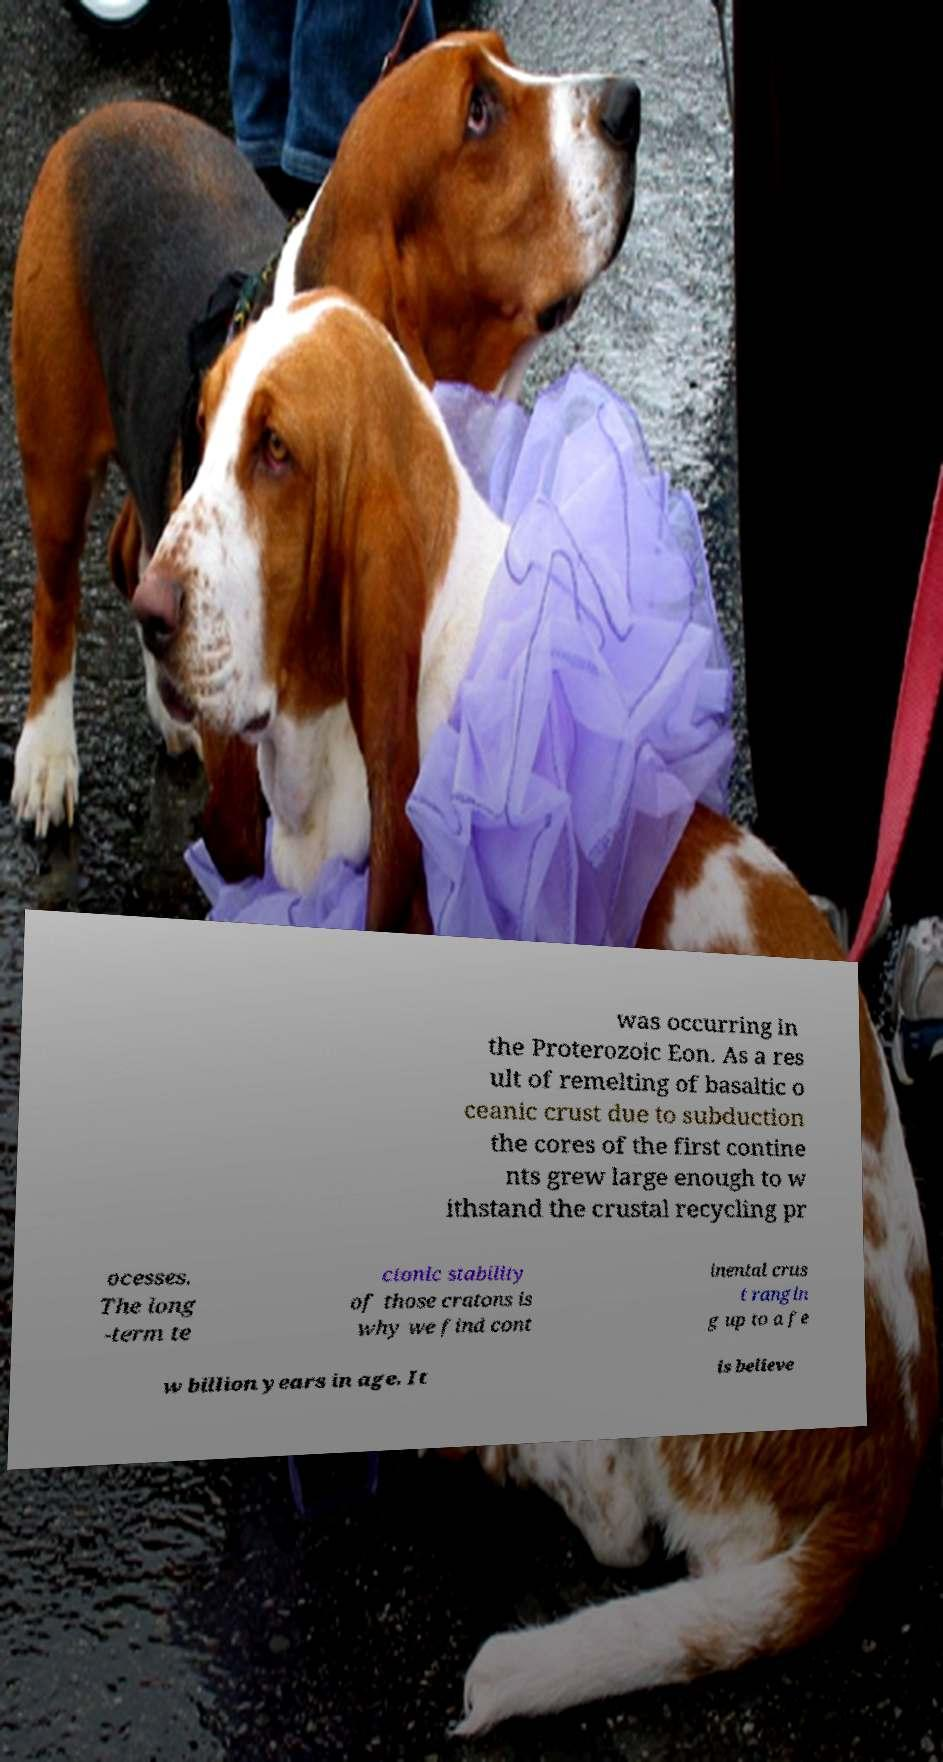I need the written content from this picture converted into text. Can you do that? was occurring in the Proterozoic Eon. As a res ult of remelting of basaltic o ceanic crust due to subduction the cores of the first contine nts grew large enough to w ithstand the crustal recycling pr ocesses. The long -term te ctonic stability of those cratons is why we find cont inental crus t rangin g up to a fe w billion years in age. It is believe 